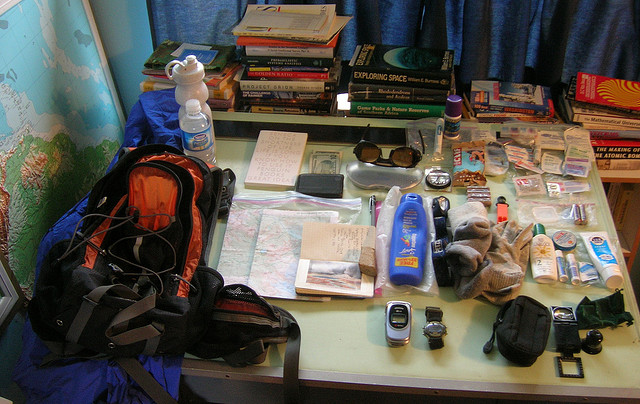What preparations seem to be made here? It looks like someone is getting ready for an adventure or a trip. The table is covered with items typically needed for traveling, like maps, a backpack, sunglasses, and a camera for documenting the journey. 